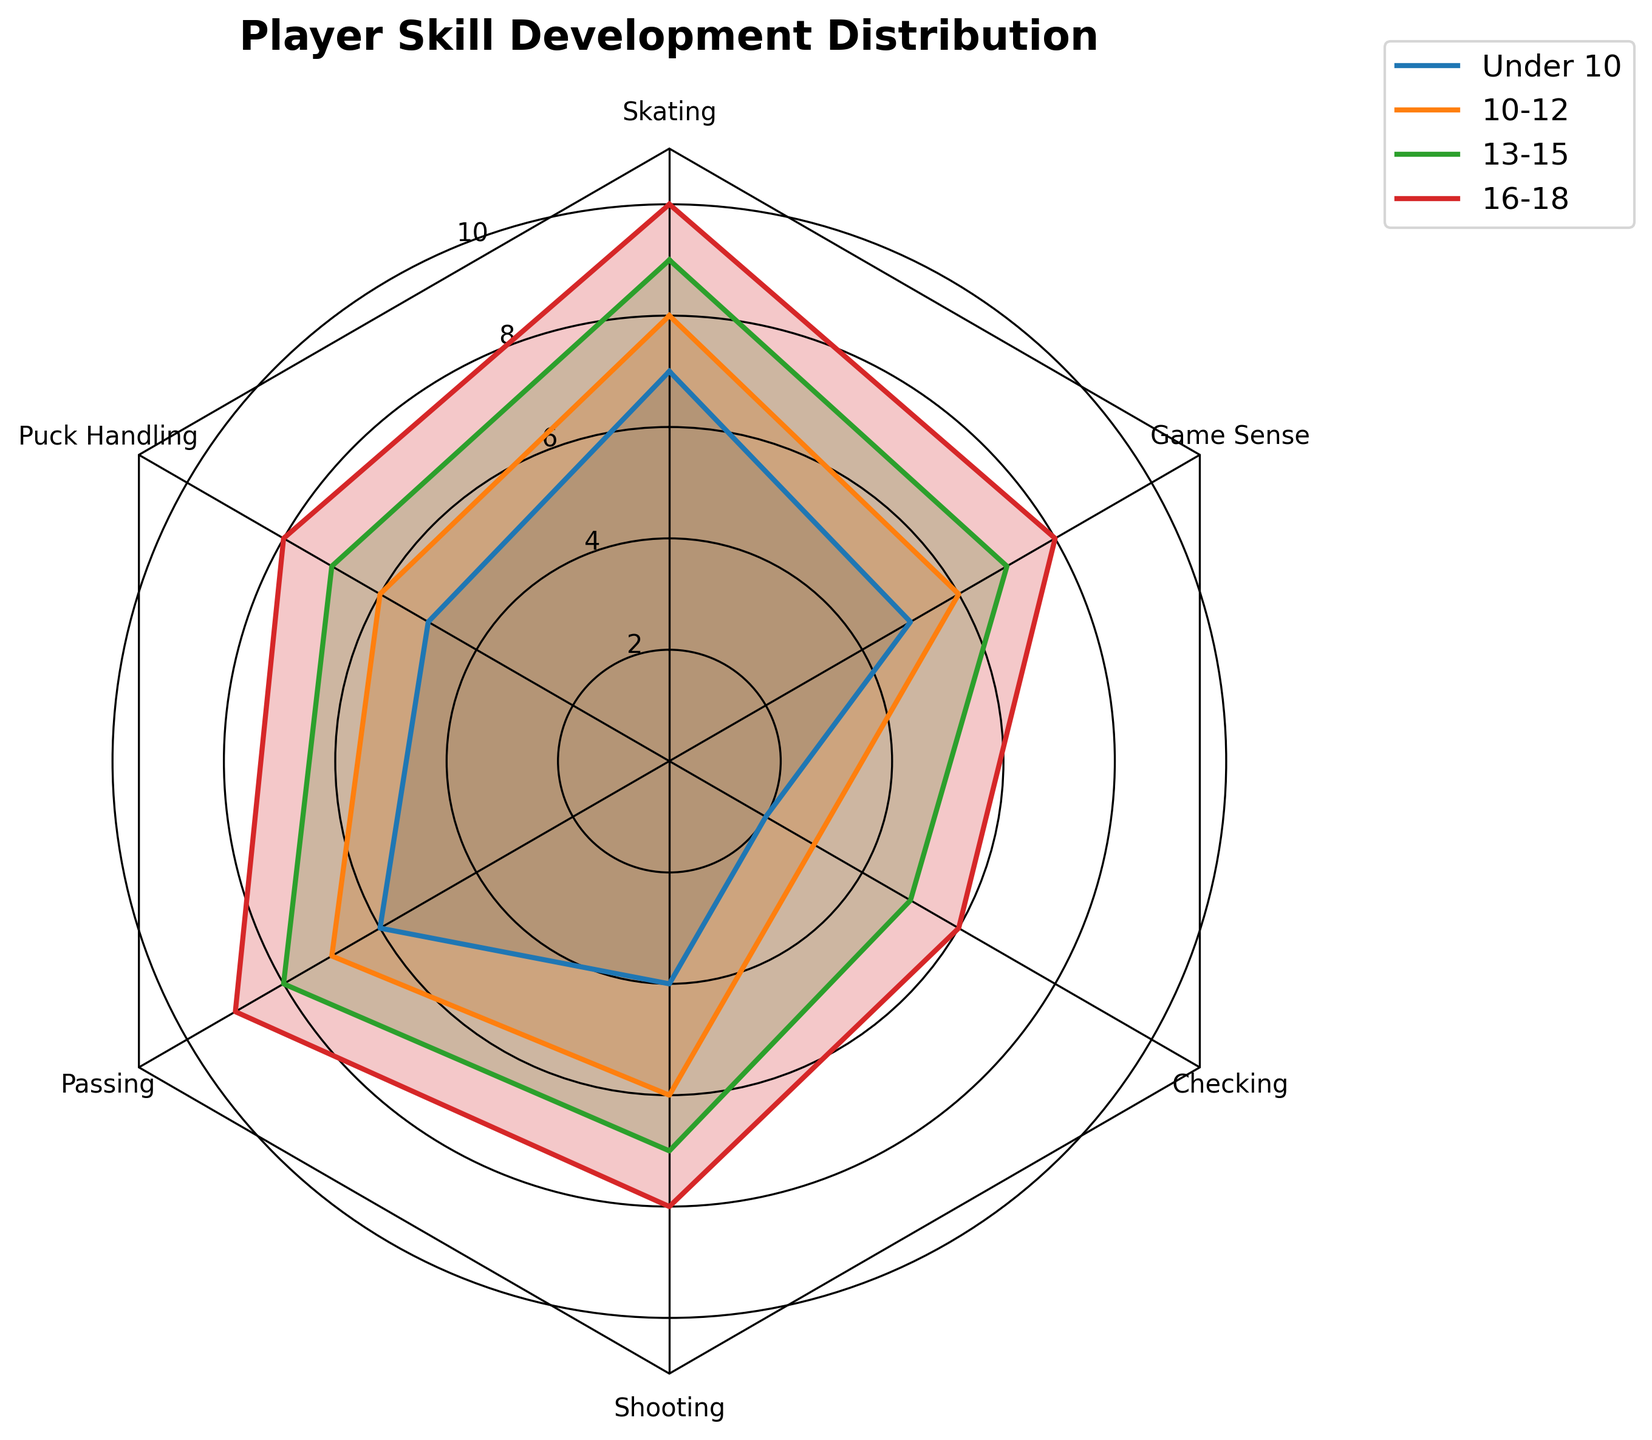What is the title of the radar chart? The title of the chart is located at the top and reads "Player Skill Development Distribution".
Answer: "Player Skill Development Distribution" Which skill is shown to have the lowest development in the Under 10 age group? By referring to the radar chart and looking at the 'Under 10' plot, the lowest value is for 'Checking' at 2.
Answer: Checking How many sets of data (age groups) are compared in the figure? The radar chart contains four different age group plots: Under 10, 10-12, 13-15, and 16-18.
Answer: Four What is the average value of all skills in the 16-18 age group? Sum all values for the 16-18 age group (10 + 8 + 9 + 8 + 6 + 8) = 49, then divide by the number of skills, 6. 49/6 = 8.17.
Answer: 8.17 Which age group has the highest shooting skill level? By looking at the plot lines for each age group and comparing the 'Shooting' values, the 16-18 age group has the highest 'Shooting' value, which is 8.
Answer: 16-18 How does the game sense skill progress from Under 10 to the 16-18 age group? The values start at 5 for Under 10, then increase to 6 for 10-12, 7 for 13-15, and finally 8 for 16-18.
Answer: Steadily increases What is the difference between the skating skills in the 10-12 and 13-15 age groups? The skating value for 13-15 is 9 and for 10-12 is 8. The difference is 9 - 8 = 1.
Answer: 1 Which two skills have the most similar values across all age groups? By comparing the plotted values across age groups, 'Passing' and 'Game Sense' have values that range closely together from 6 to 9 and 5 to 8, respectively.
Answer: Passing and Game Sense In which age group does checking show the most significant increase compared to its previous age group? Comparing the 'Checking' values, the largest change is from age group 13-15 (5) to 16-18 (6), an increase of 1.
Answer: 16-18 What is the combined total of puck handling scores for all age groups? Add all values for 'Puck Handling' across age groups: 5 (Under 10) + 6 (10-12) + 7 (13-15) + 8 (16-18) = 26.
Answer: 26 